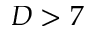<formula> <loc_0><loc_0><loc_500><loc_500>D > 7</formula> 